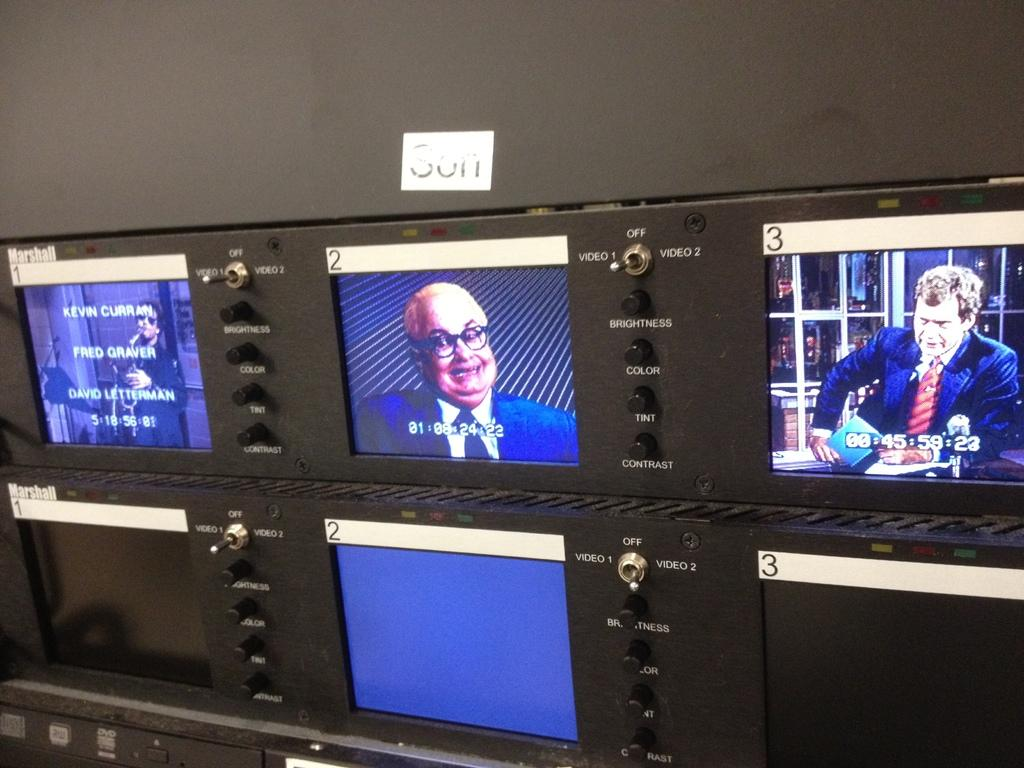<image>
Summarize the visual content of the image. A row of monitors is showing different TV channels and a tag above them says Son. 